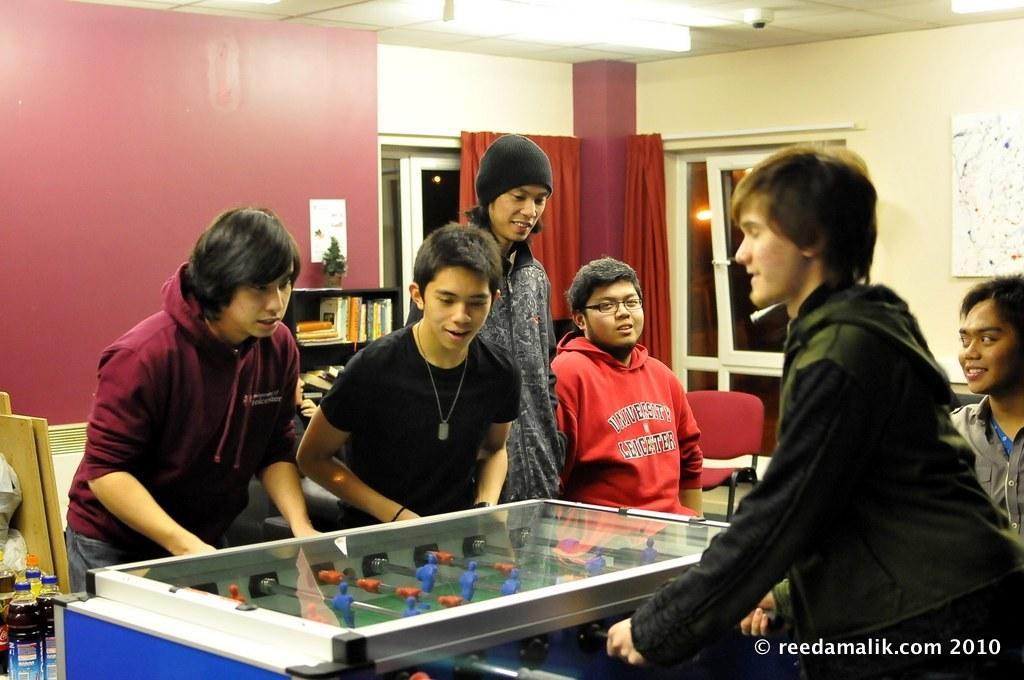Who or what can be seen in the image? There are people in the image. What type of game or activity is featured in the image? There is a Foosball table in the image. What can be seen outside the windows in the image? There are windows in the image, but the facts do not specify what can be seen outside. What type of window treatment is present in the image? There are curtains in the image. What type of items can be seen on the shelves in the image? There are shelves filled with books in the image. What other objects are present in the image? The facts mention that there are other objects present in the image, but do not specify what they are. What type of animal's tail can be seen hanging from the Foosball table in the image? There is no animal tail present on the Foosball table in the image. What type of clouds can be seen outside the windows in the image? The facts do not specify what can be seen outside the windows in the image, so we cannot determine if there are clouds present. 